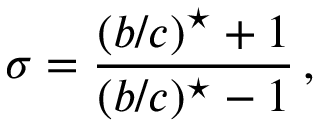Convert formula to latex. <formula><loc_0><loc_0><loc_500><loc_500>\sigma = \frac { ( b / c ) ^ { ^ { * } } + 1 } { ( b / c ) ^ { ^ { * } } - 1 } \, ,</formula> 